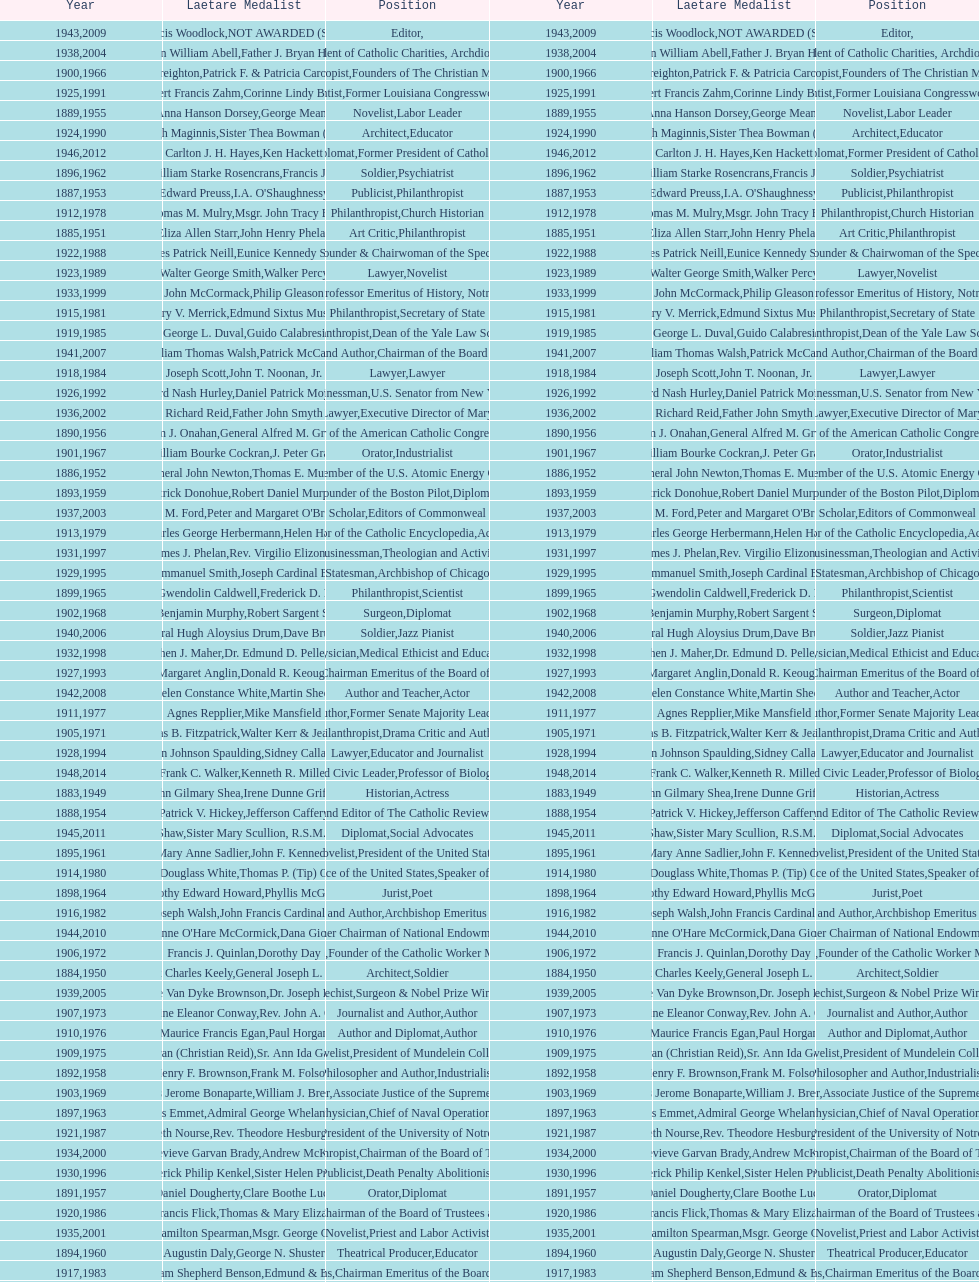Would you mind parsing the complete table? {'header': ['Year', 'Laetare Medalist', 'Position', 'Year', 'Laetare Medalist', 'Position'], 'rows': [['1943', 'Thomas Francis Woodlock', 'Editor', '2009', 'NOT AWARDED (SEE BELOW)', ''], ['1938', 'Irvin William Abell', 'Surgeon', '2004', 'Father J. Bryan Hehir', 'President of Catholic Charities, Archdiocese of Boston'], ['1900', 'John A. Creighton', 'Philanthropist', '1966', 'Patrick F. & Patricia Caron Crowley', 'Founders of The Christian Movement'], ['1925', 'Albert Francis Zahm', 'Scientist', '1991', 'Corinne Lindy Boggs', 'Former Louisiana Congresswoman'], ['1889', 'Anna Hanson Dorsey', 'Novelist', '1955', 'George Meany', 'Labor Leader'], ['1924', 'Charles Donagh Maginnis', 'Architect', '1990', 'Sister Thea Bowman (posthumously)', 'Educator'], ['1946', 'Carlton J. H. Hayes', 'Historian and Diplomat', '2012', 'Ken Hackett', 'Former President of Catholic Relief Services'], ['1896', 'General William Starke Rosencrans', 'Soldier', '1962', 'Francis J. Braceland', 'Psychiatrist'], ['1887', 'Edward Preuss', 'Publicist', '1953', "I.A. O'Shaughnessy", 'Philanthropist'], ['1912', 'Thomas M. Mulry', 'Philanthropist', '1978', 'Msgr. John Tracy Ellis', 'Church Historian'], ['1885', 'Eliza Allen Starr', 'Art Critic', '1951', 'John Henry Phelan', 'Philanthropist'], ['1922', 'Charles Patrick Neill', 'Economist', '1988', 'Eunice Kennedy Shriver', 'Founder & Chairwoman of the Special Olympics'], ['1923', 'Walter George Smith', 'Lawyer', '1989', 'Walker Percy', 'Novelist'], ['1933', 'John McCormack', 'Artist', '1999', 'Philip Gleason', 'Professor Emeritus of History, Notre Dame'], ['1915', 'Mary V. Merrick', 'Philanthropist', '1981', 'Edmund Sixtus Muskie', 'Secretary of State'], ['1919', 'George L. Duval', 'Philanthropist', '1985', 'Guido Calabresi', 'Dean of the Yale Law School'], ['1941', 'William Thomas Walsh', 'Journalist and Author', '2007', 'Patrick McCartan', 'Chairman of the Board of Trustees'], ['1918', 'Joseph Scott', 'Lawyer', '1984', 'John T. Noonan, Jr.', 'Lawyer'], ['1926', 'Edward Nash Hurley', 'Businessman', '1992', 'Daniel Patrick Moynihan', 'U.S. Senator from New York'], ['1936', 'Richard Reid', 'Journalist and Lawyer', '2002', 'Father John Smyth', 'Executive Director of Maryville Academy'], ['1890', 'William J. Onahan', 'Organizer of the American Catholic Congress', '1956', 'General Alfred M. Gruenther', 'Soldier'], ['1901', 'William Bourke Cockran', 'Orator', '1967', 'J. Peter Grace', 'Industrialist'], ['1886', 'General John Newton', 'Engineer', '1952', 'Thomas E. Murray', 'Member of the U.S. Atomic Energy Commission'], ['1893', 'Patrick Donohue', 'Founder of the Boston Pilot', '1959', 'Robert Daniel Murphy', 'Diplomat'], ['1937', 'Jeremiah D. M. Ford', 'Scholar', '2003', "Peter and Margaret O'Brien Steinfels", 'Editors of Commonweal'], ['1913', 'Charles George Herbermann', 'Editor of the Catholic Encyclopedia', '1979', 'Helen Hayes', 'Actress'], ['1931', 'James J. Phelan', 'Businessman', '1997', 'Rev. Virgilio Elizondo', 'Theologian and Activist'], ['1929', 'Alfred Emmanuel Smith', 'Statesman', '1995', 'Joseph Cardinal Bernardin', 'Archbishop of Chicago'], ['1899', 'Mary Gwendolin Caldwell', 'Philanthropist', '1965', 'Frederick D. Rossini', 'Scientist'], ['1902', 'John Benjamin Murphy', 'Surgeon', '1968', 'Robert Sargent Shriver', 'Diplomat'], ['1940', 'General Hugh Aloysius Drum', 'Soldier', '2006', 'Dave Brubeck', 'Jazz Pianist'], ['1932', 'Stephen J. Maher', 'Physician', '1998', 'Dr. Edmund D. Pellegrino', 'Medical Ethicist and Educator'], ['1927', 'Margaret Anglin', 'Actress', '1993', 'Donald R. Keough', 'Chairman Emeritus of the Board of Trustees'], ['1942', 'Helen Constance White', 'Author and Teacher', '2008', 'Martin Sheen', 'Actor'], ['1911', 'Agnes Repplier', 'Author', '1977', 'Mike Mansfield', 'Former Senate Majority Leader'], ['1905', 'Thomas B. Fitzpatrick', 'Philanthropist', '1971', 'Walter Kerr & Jean Kerr', 'Drama Critic and Author'], ['1928', 'John Johnson Spaulding', 'Lawyer', '1994', 'Sidney Callahan', 'Educator and Journalist'], ['1948', 'Frank C. Walker', 'Postmaster General and Civic Leader', '2014', 'Kenneth R. Miller', 'Professor of Biology at Brown University'], ['1883', 'John Gilmary Shea', 'Historian', '1949', 'Irene Dunne Griffin', 'Actress'], ['1888', 'Patrick V. Hickey', 'Founder and Editor of The Catholic Review', '1954', 'Jefferson Caffery', 'Diplomat'], ['1945', 'Gardiner Howland Shaw', 'Diplomat', '2011', 'Sister Mary Scullion, R.S.M., & Joan McConnon', 'Social Advocates'], ['1895', 'Mary Anne Sadlier', 'Novelist', '1961', 'John F. Kennedy', 'President of the United States'], ['1914', 'Edward Douglass White', 'Chief Justice of the United States', '1980', "Thomas P. (Tip) O'Neill Jr.", 'Speaker of the House'], ['1898', 'Timothy Edward Howard', 'Jurist', '1964', 'Phyllis McGinley', 'Poet'], ['1916', 'James Joseph Walsh', 'Physician and Author', '1982', 'John Francis Cardinal Dearden', 'Archbishop Emeritus of Detroit'], ['1944', "Anne O'Hare McCormick", 'Journalist', '2010', 'Dana Gioia', 'Former Chairman of National Endowment for the Arts'], ['1906', 'Francis J. Quinlan', 'Physician', '1972', 'Dorothy Day', 'Founder of the Catholic Worker Movement'], ['1884', 'Patrick Charles Keely', 'Architect', '1950', 'General Joseph L. Collins', 'Soldier'], ['1939', 'Josephine Van Dyke Brownson', 'Catechist', '2005', 'Dr. Joseph E. Murray', 'Surgeon & Nobel Prize Winner'], ['1907', 'Katherine Eleanor Conway', 'Journalist and Author', '1973', "Rev. John A. O'Brien", 'Author'], ['1910', 'Maurice Francis Egan', 'Author and Diplomat', '1976', 'Paul Horgan', 'Author'], ['1909', 'Frances Tieran (Christian Reid)', 'Novelist', '1975', 'Sr. Ann Ida Gannon, BMV', 'President of Mundelein College'], ['1892', 'Henry F. Brownson', 'Philosopher and Author', '1958', 'Frank M. Folsom', 'Industrialist'], ['1903', 'Charles Jerome Bonaparte', 'Lawyer', '1969', 'William J. Brennan Jr.', 'Associate Justice of the Supreme Court'], ['1897', 'Thomas Addis Emmet', 'Physician', '1963', 'Admiral George Whelan Anderson, Jr.', 'Chief of Naval Operations'], ['1921', 'Elizabeth Nourse', 'Artist', '1987', 'Rev. Theodore Hesburgh, CSC', 'President of the University of Notre Dame'], ['1934', 'Genevieve Garvan Brady', 'Philanthropist', '2000', 'Andrew McKenna', 'Chairman of the Board of Trustees'], ['1930', 'Frederick Philip Kenkel', 'Publicist', '1996', 'Sister Helen Prejean', 'Death Penalty Abolitionist'], ['1891', 'Daniel Dougherty', 'Orator', '1957', 'Clare Boothe Luce', 'Diplomat'], ['1920', 'Lawrence Francis Flick', 'Physician', '1986', 'Thomas & Mary Elizabeth Carney', 'Chairman of the Board of Trustees and his wife'], ['1935', 'Francis Hamilton Spearman', 'Novelist', '2001', 'Msgr. George G. Higgins', 'Priest and Labor Activist'], ['1894', 'Augustin Daly', 'Theatrical Producer', '1960', 'George N. Shuster', 'Educator'], ['1917', 'Admiral William Shepherd Benson', 'Chief of Naval Operations', '1983', 'Edmund & Evelyn Stephan', 'Chairman Emeritus of the Board of Trustees and his wife'], ['1908', 'James C. Monaghan', 'Economist', '1974', 'James A. Farley', 'Business Executive and Former Postmaster General'], ['1947', 'William G. Bruce', 'Publisher and Civic Leader', '2013', 'Sister Susanne Gallagher, S.P.\\nSister Mary Therese Harrington, S.H.\\nRev. James H. McCarthy', 'Founders of S.P.R.E.D. (Special Religious Education Development Network)'], ['1904', 'Richard C. Kerens', 'Diplomat', '1970', 'Dr. William B. Walsh', 'Physician']]} How many laetare medalists were philantrohpists? 2. 